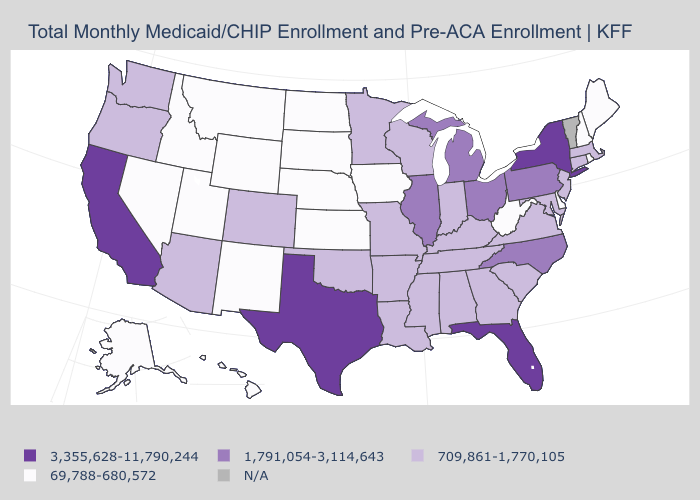Among the states that border Utah , does Colorado have the highest value?
Quick response, please. Yes. Name the states that have a value in the range 69,788-680,572?
Concise answer only. Alaska, Delaware, Hawaii, Idaho, Iowa, Kansas, Maine, Montana, Nebraska, Nevada, New Hampshire, New Mexico, North Dakota, Rhode Island, South Dakota, Utah, West Virginia, Wyoming. Which states have the lowest value in the USA?
Write a very short answer. Alaska, Delaware, Hawaii, Idaho, Iowa, Kansas, Maine, Montana, Nebraska, Nevada, New Hampshire, New Mexico, North Dakota, Rhode Island, South Dakota, Utah, West Virginia, Wyoming. What is the value of West Virginia?
Answer briefly. 69,788-680,572. Is the legend a continuous bar?
Be succinct. No. Name the states that have a value in the range 3,355,628-11,790,244?
Be succinct. California, Florida, New York, Texas. Does Nevada have the lowest value in the West?
Give a very brief answer. Yes. Among the states that border Kentucky , does West Virginia have the lowest value?
Give a very brief answer. Yes. Which states have the highest value in the USA?
Give a very brief answer. California, Florida, New York, Texas. Which states hav the highest value in the Northeast?
Give a very brief answer. New York. Among the states that border Wyoming , does Utah have the highest value?
Quick response, please. No. What is the highest value in the USA?
Write a very short answer. 3,355,628-11,790,244. Which states have the lowest value in the USA?
Answer briefly. Alaska, Delaware, Hawaii, Idaho, Iowa, Kansas, Maine, Montana, Nebraska, Nevada, New Hampshire, New Mexico, North Dakota, Rhode Island, South Dakota, Utah, West Virginia, Wyoming. 